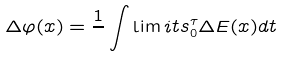<formula> <loc_0><loc_0><loc_500><loc_500>\Delta \varphi ( x ) = \frac { 1 } { } \int \lim i t s _ { 0 } ^ { \tau } \Delta E ( x ) d t</formula> 